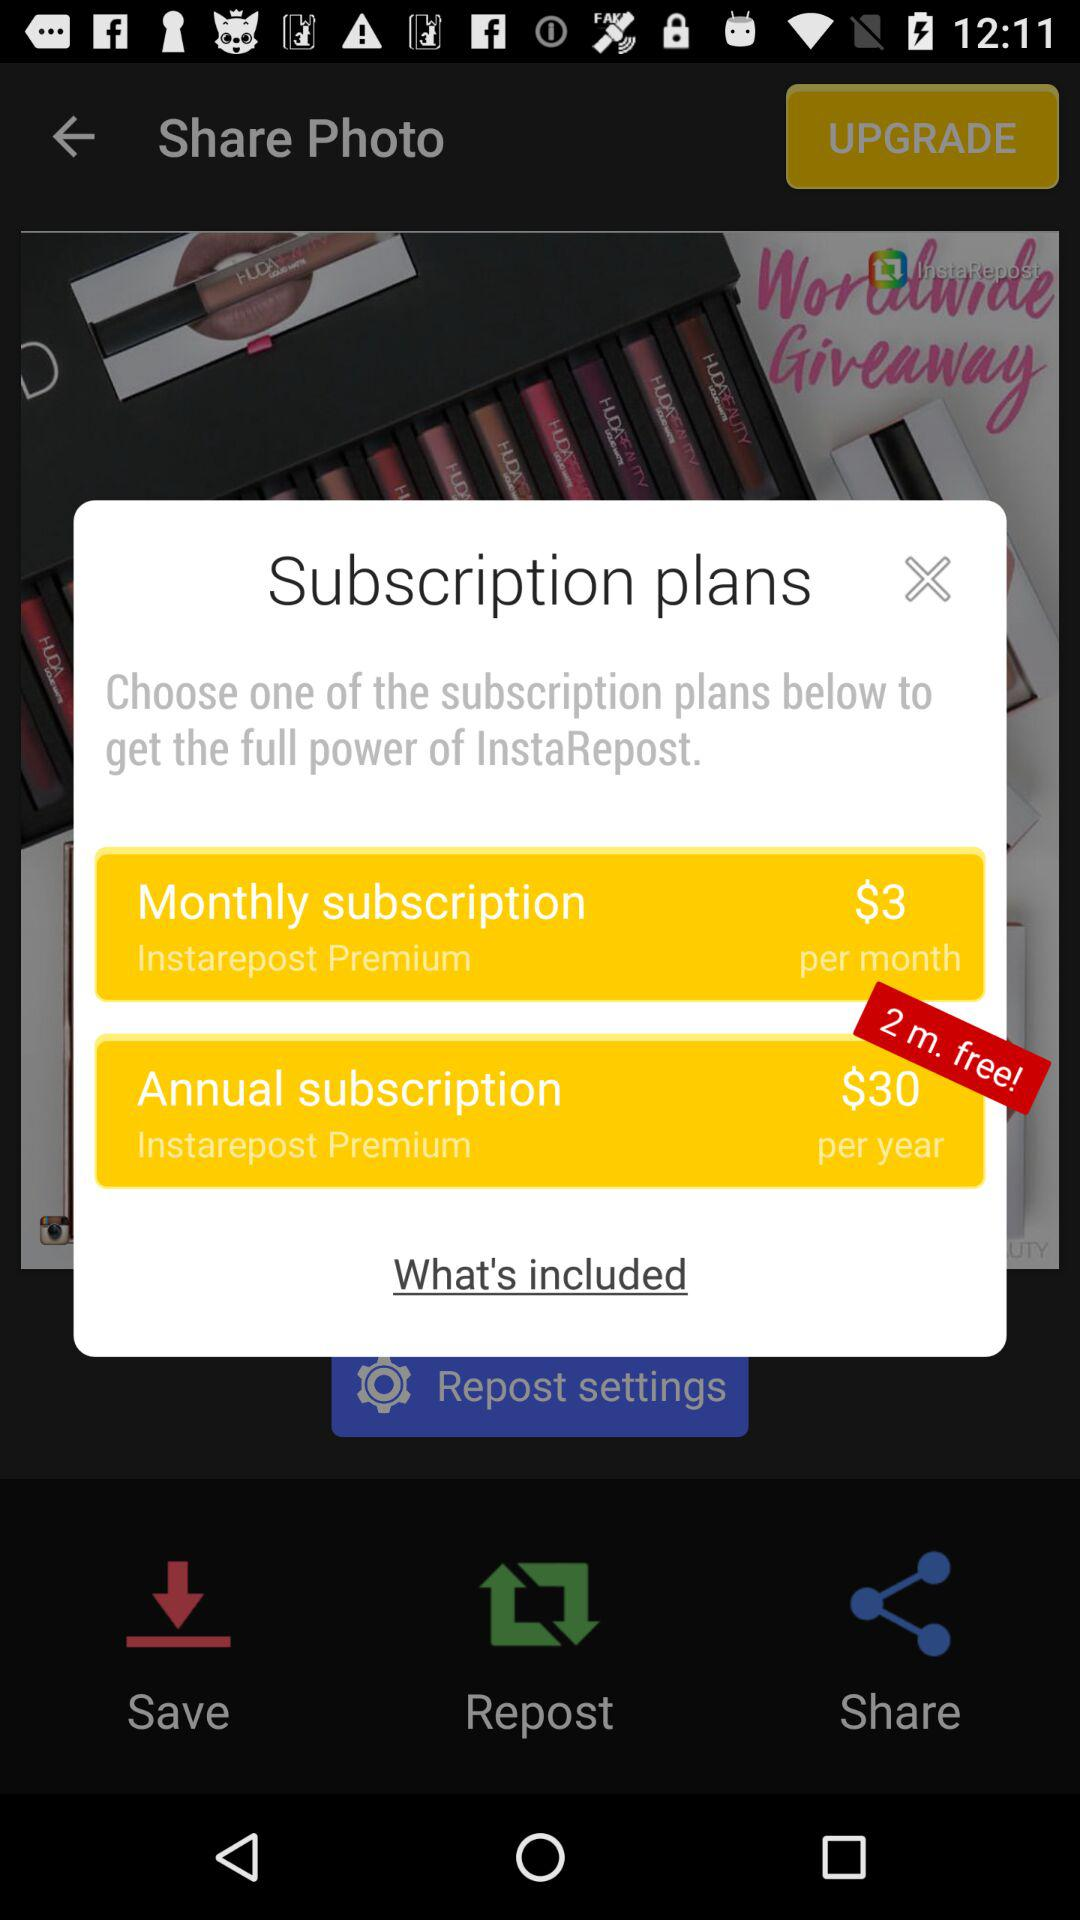How many photos were saved?
When the provided information is insufficient, respond with <no answer>. <no answer> 